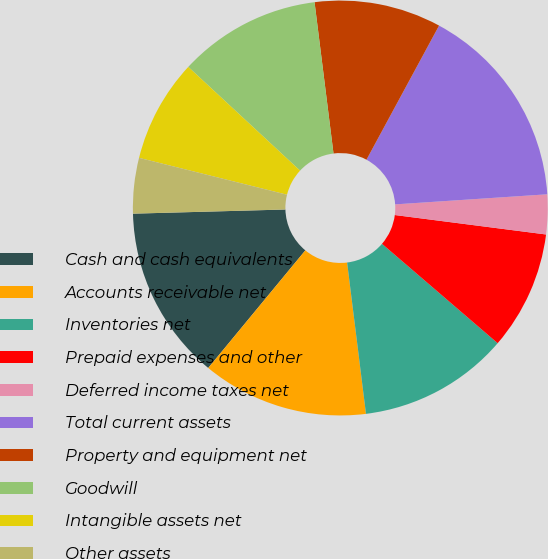<chart> <loc_0><loc_0><loc_500><loc_500><pie_chart><fcel>Cash and cash equivalents<fcel>Accounts receivable net<fcel>Inventories net<fcel>Prepaid expenses and other<fcel>Deferred income taxes net<fcel>Total current assets<fcel>Property and equipment net<fcel>Goodwill<fcel>Intangible assets net<fcel>Other assets<nl><fcel>13.58%<fcel>12.96%<fcel>11.73%<fcel>9.26%<fcel>3.09%<fcel>16.05%<fcel>9.88%<fcel>11.11%<fcel>8.02%<fcel>4.32%<nl></chart> 